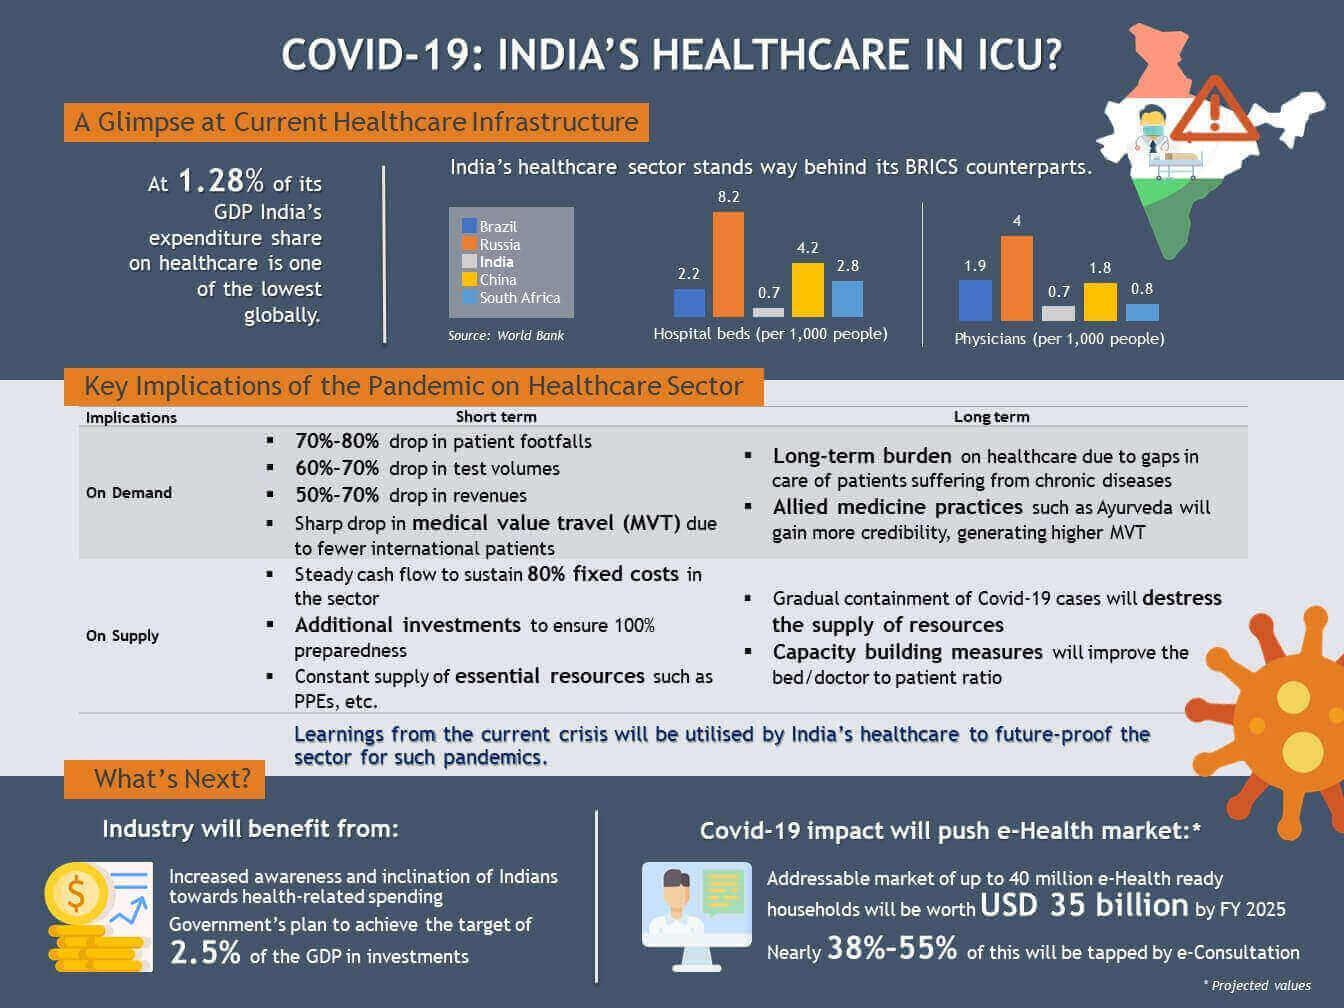How many physicians are available per 1000 people in China?
Answer the question with a short phrase. 1.8 What is the number of hospital beds per 1,000 people in Russia? 8.2 